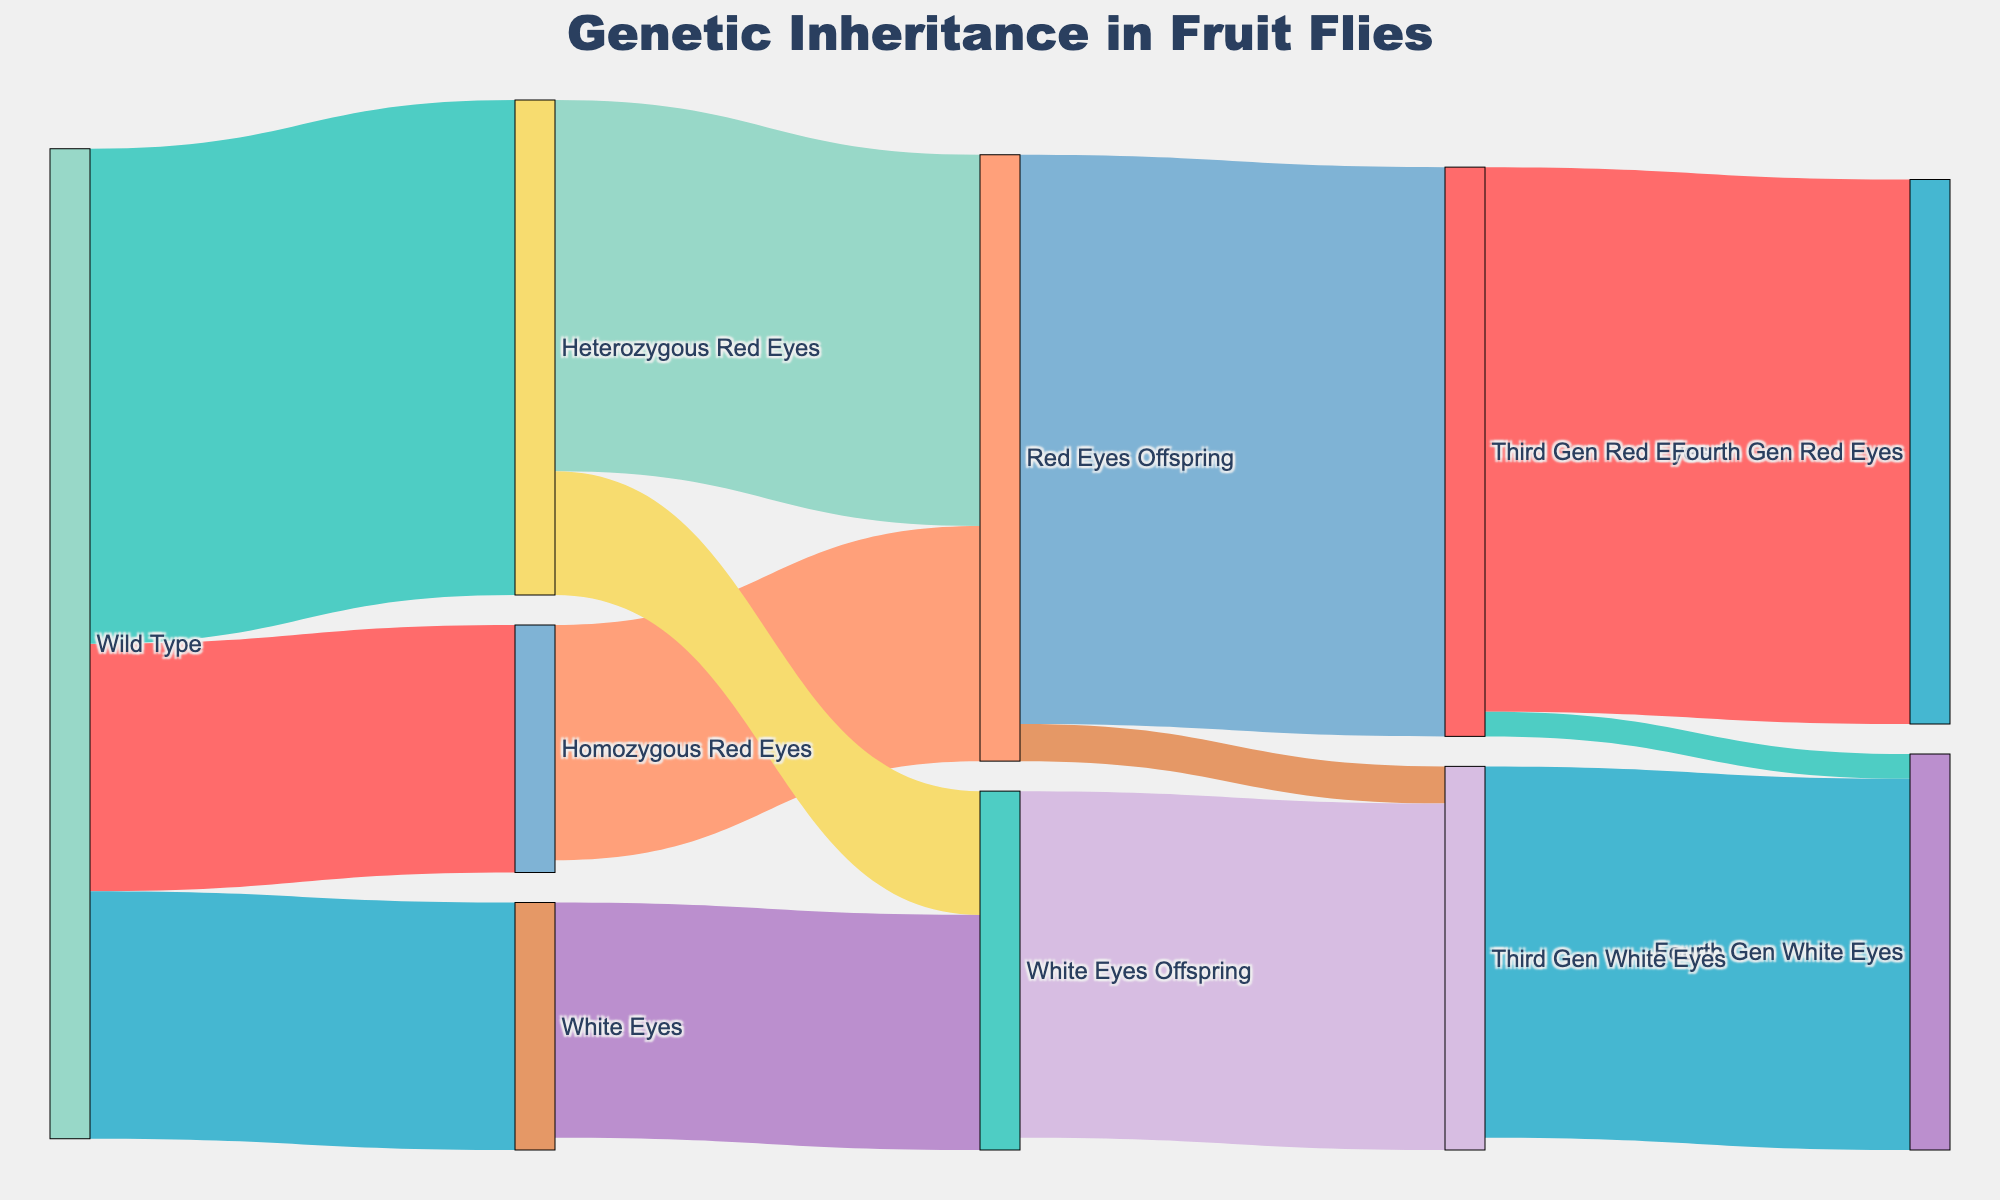What is the total number of 'Red Eyes Offspring' from 'Homozygous Red Eyes' and 'Heterozygous Red Eyes'? Add the values of 'Red Eyes Offspring' from both 'Homozygous Red Eyes' (95) and 'Heterozygous Red Eyes' (150)
Answer: 245 Which category has the highest value among the direct offspring from 'Wild Type'? Compare the values linked to 'Wild Type': Homozygous Red Eyes (100), Heterozygous Red Eyes (200), and White Eyes (100). The highest is 200 from 'Heterozygous Red Eyes'
Answer: Heterozygous Red Eyes What is the total number of fourth generation red-eyed and white-eyed fruit flies? Add the values of 'Fourth Gen Red Eyes' (220) and 'Fourth Gen White Eyes' (160) from 'Third Gen Red Eyes' and 'Third Gen White Eyes'
Answer: 380 Which generation has more instances of white-eyed offspring, the first or the third? Compare the sum of white-eyed offspring in each generation: First generation (Wild Type to White Eyes, 100) vs. Third generation (Red Eyes Offspring to Third Gen White Eyes, 15 + White Eyes Offspring to Third Gen White Eyes, 140). First generation has 100, while the third generation has 155
Answer: Third generation How many offspring are there in total at the second generation? Add all the offspring values in the second generation: 'Homozygous Red Eyes to Red Eyes Offspring' (95), 'Heterozygous Red Eyes to Red Eyes Offspring' (150), 'Heterozygous Red Eyes to White Eyes Offspring' (50), and 'White Eyes to White Eyes Offspring' (95)
Answer: 390 Which group has the smallest number of third-generation white-eyed fruit flies? Compare 'Red Eyes Offspring to Third Gen White Eyes' (15) and 'White Eyes Offspring to Third Gen White Eyes' (140), the smallest group is from 'Red Eyes Offspring'
Answer: Red Eyes Offspring to Third Gen White Eyes How many total sources lead to 'Third Gen Red Eyes'? Count the links leading to 'Third Gen Red Eyes': Only 'Red Eyes Offspring' (1 source)
Answer: 1 What percentage of the first generation's heterozygous red-eyed fruit flies become white-eyed offspring in the second generation? The total heterozygous red-eyed fruit flies in the first generation is 200. The heterozygous red-eyed that become white-eyed offspring is 50. The percentage is (50 / 200) * 100%
Answer: 25% What is the value difference between 'Red Eyes Offspring' and 'White Eyes Offspring' from the second generation's Heterozygous Red Eyes? Subtract the value of 'White Eyes Offspring' (50) from 'Red Eyes Offspring' (150): 150 - 50
Answer: 100 Which fourth generation group receives the least number of offspring? Compare 'Fourth Gen Red Eyes' (220), 'Fourth Gen White Eyes' from Third Gen Red Eyes (10), and 'Fourth Gen White Eyes' from Third Gen White Eyes (150). The least is 'Fourth Gen White Eyes' from Third Gen Red Eyes (10)
Answer: Fourth Gen White Eyes from Third Gen Red Eyes 